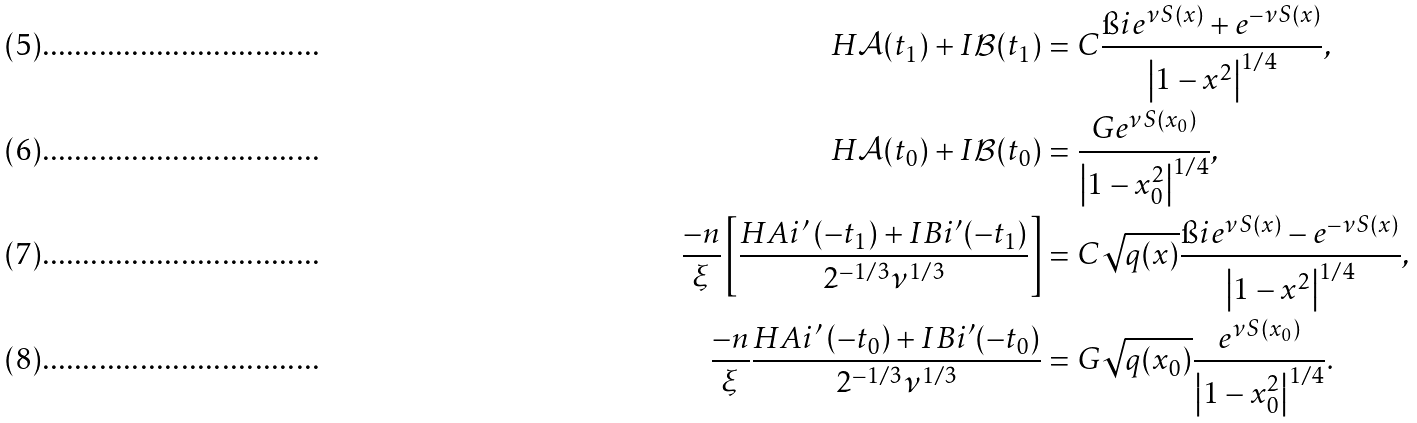Convert formula to latex. <formula><loc_0><loc_0><loc_500><loc_500>H \mathcal { A } ( t _ { 1 } ) + I \mathcal { B } ( t _ { 1 } ) & = C \frac { \i i e ^ { \nu S ( x ) } + e ^ { - \nu S ( x ) } } { \left | 1 - x ^ { 2 } \right | ^ { 1 / 4 } } , \\ H \mathcal { A } ( t _ { 0 } ) + I \mathcal { B } ( t _ { 0 } ) & = \frac { G e ^ { \nu S ( x _ { 0 } ) } } { \left | 1 - x _ { 0 } ^ { 2 } \right | ^ { 1 / 4 } } , \\ \frac { - n } { \xi } \left [ \frac { H A i ^ { \prime } \left ( - t _ { 1 } \right ) + I B i ^ { \prime } ( - t _ { 1 } ) } { 2 ^ { - 1 / 3 } \nu ^ { 1 / 3 } } \right ] & = C \sqrt { q ( x ) } \frac { \i i e ^ { \nu S ( x ) } - e ^ { - \nu S ( x ) } } { \left | 1 - x ^ { 2 } \right | ^ { 1 / 4 } } , \\ \frac { - n } { \xi } \frac { H A i ^ { \prime } \left ( - t _ { 0 } \right ) + I B i ^ { \prime } ( - t _ { 0 } ) } { 2 ^ { - 1 / 3 } \nu ^ { 1 / 3 } } & = G \sqrt { q ( x _ { 0 } ) } \frac { e ^ { \nu S ( x _ { 0 } ) } } { \left | 1 - x _ { 0 } ^ { 2 } \right | ^ { 1 / 4 } } .</formula> 